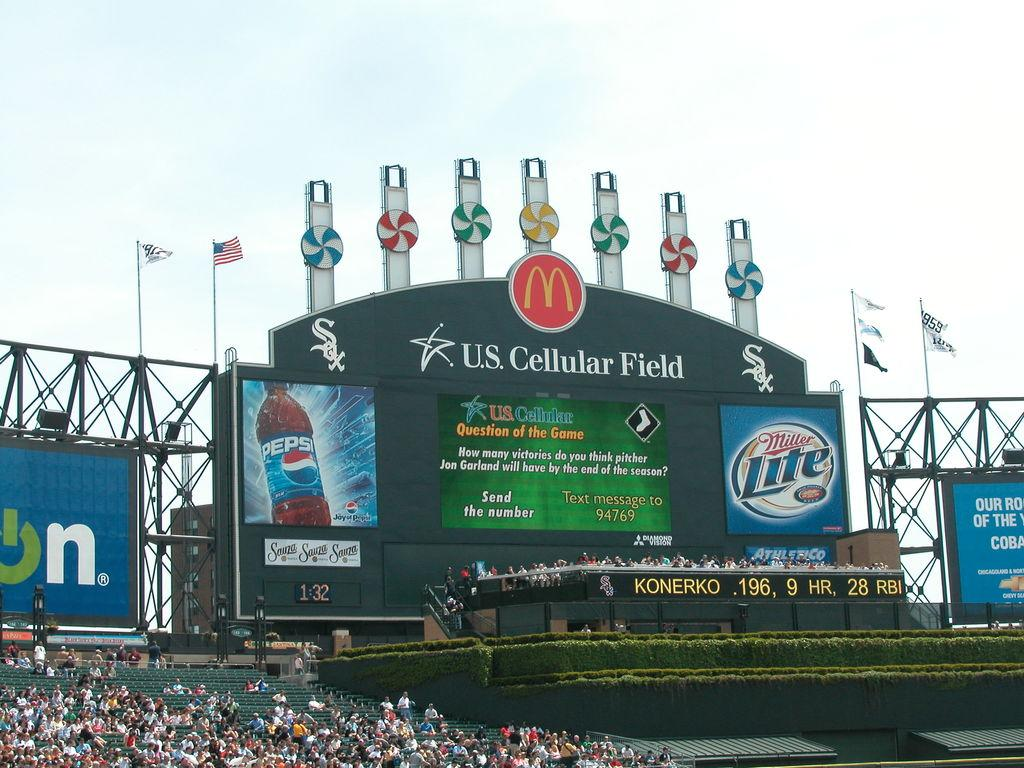<image>
Relay a brief, clear account of the picture shown. The scoreboard at U.S. Cellular Field features advertisements for Pepsi and Miller Lite. 